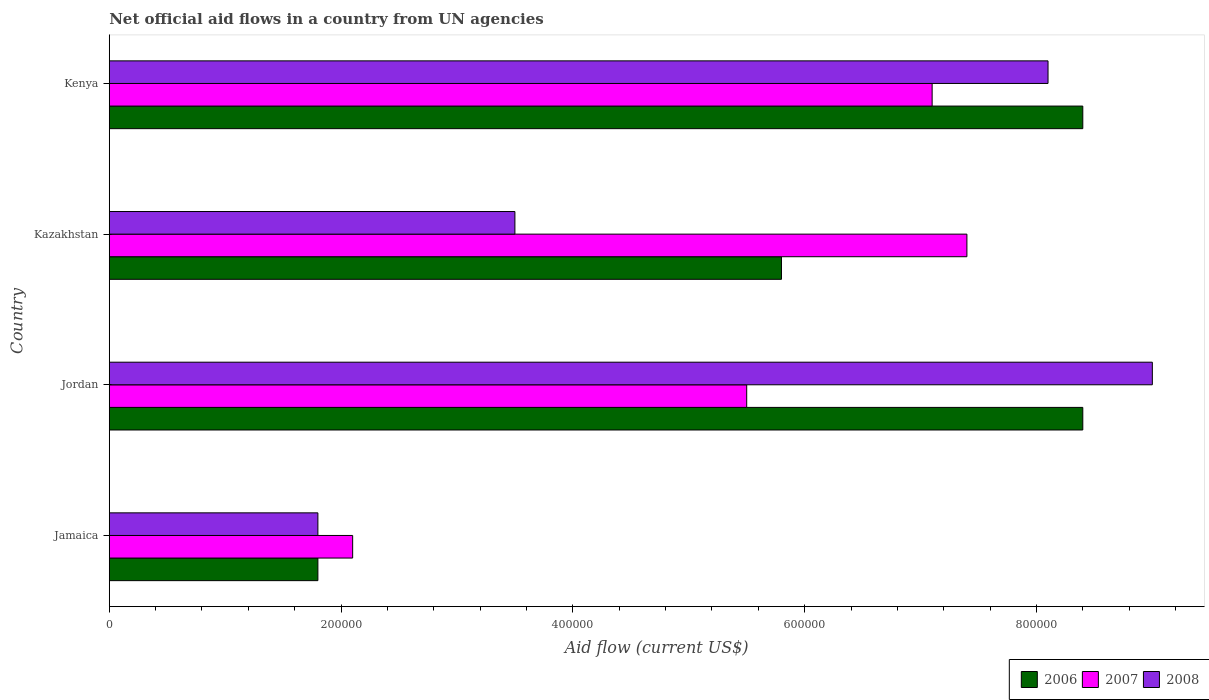How many groups of bars are there?
Your answer should be compact. 4. Are the number of bars on each tick of the Y-axis equal?
Make the answer very short. Yes. How many bars are there on the 2nd tick from the top?
Ensure brevity in your answer.  3. What is the label of the 3rd group of bars from the top?
Your answer should be compact. Jordan. Across all countries, what is the maximum net official aid flow in 2007?
Keep it short and to the point. 7.40e+05. In which country was the net official aid flow in 2006 maximum?
Your answer should be very brief. Jordan. In which country was the net official aid flow in 2006 minimum?
Keep it short and to the point. Jamaica. What is the total net official aid flow in 2006 in the graph?
Give a very brief answer. 2.44e+06. What is the difference between the net official aid flow in 2008 in Kazakhstan and that in Kenya?
Your answer should be very brief. -4.60e+05. What is the average net official aid flow in 2007 per country?
Your answer should be compact. 5.52e+05. What is the ratio of the net official aid flow in 2006 in Jamaica to that in Jordan?
Offer a very short reply. 0.21. Is the net official aid flow in 2006 in Jordan less than that in Kazakhstan?
Keep it short and to the point. No. What is the difference between the highest and the lowest net official aid flow in 2007?
Make the answer very short. 5.30e+05. In how many countries, is the net official aid flow in 2007 greater than the average net official aid flow in 2007 taken over all countries?
Your answer should be very brief. 2. Is the sum of the net official aid flow in 2008 in Kazakhstan and Kenya greater than the maximum net official aid flow in 2007 across all countries?
Provide a short and direct response. Yes. What does the 1st bar from the top in Kenya represents?
Your answer should be compact. 2008. Is it the case that in every country, the sum of the net official aid flow in 2007 and net official aid flow in 2008 is greater than the net official aid flow in 2006?
Give a very brief answer. Yes. How many bars are there?
Offer a very short reply. 12. How many countries are there in the graph?
Provide a succinct answer. 4. What is the difference between two consecutive major ticks on the X-axis?
Provide a succinct answer. 2.00e+05. Are the values on the major ticks of X-axis written in scientific E-notation?
Ensure brevity in your answer.  No. Does the graph contain any zero values?
Offer a terse response. No. What is the title of the graph?
Offer a very short reply. Net official aid flows in a country from UN agencies. What is the label or title of the X-axis?
Keep it short and to the point. Aid flow (current US$). What is the label or title of the Y-axis?
Your answer should be very brief. Country. What is the Aid flow (current US$) in 2006 in Jamaica?
Provide a succinct answer. 1.80e+05. What is the Aid flow (current US$) in 2008 in Jamaica?
Make the answer very short. 1.80e+05. What is the Aid flow (current US$) of 2006 in Jordan?
Ensure brevity in your answer.  8.40e+05. What is the Aid flow (current US$) of 2008 in Jordan?
Make the answer very short. 9.00e+05. What is the Aid flow (current US$) in 2006 in Kazakhstan?
Give a very brief answer. 5.80e+05. What is the Aid flow (current US$) of 2007 in Kazakhstan?
Ensure brevity in your answer.  7.40e+05. What is the Aid flow (current US$) of 2006 in Kenya?
Keep it short and to the point. 8.40e+05. What is the Aid flow (current US$) of 2007 in Kenya?
Offer a terse response. 7.10e+05. What is the Aid flow (current US$) in 2008 in Kenya?
Ensure brevity in your answer.  8.10e+05. Across all countries, what is the maximum Aid flow (current US$) of 2006?
Give a very brief answer. 8.40e+05. Across all countries, what is the maximum Aid flow (current US$) in 2007?
Your response must be concise. 7.40e+05. Across all countries, what is the minimum Aid flow (current US$) of 2007?
Provide a succinct answer. 2.10e+05. Across all countries, what is the minimum Aid flow (current US$) in 2008?
Ensure brevity in your answer.  1.80e+05. What is the total Aid flow (current US$) in 2006 in the graph?
Provide a succinct answer. 2.44e+06. What is the total Aid flow (current US$) of 2007 in the graph?
Your answer should be compact. 2.21e+06. What is the total Aid flow (current US$) in 2008 in the graph?
Make the answer very short. 2.24e+06. What is the difference between the Aid flow (current US$) of 2006 in Jamaica and that in Jordan?
Give a very brief answer. -6.60e+05. What is the difference between the Aid flow (current US$) of 2008 in Jamaica and that in Jordan?
Provide a succinct answer. -7.20e+05. What is the difference between the Aid flow (current US$) of 2006 in Jamaica and that in Kazakhstan?
Keep it short and to the point. -4.00e+05. What is the difference between the Aid flow (current US$) in 2007 in Jamaica and that in Kazakhstan?
Offer a very short reply. -5.30e+05. What is the difference between the Aid flow (current US$) of 2008 in Jamaica and that in Kazakhstan?
Keep it short and to the point. -1.70e+05. What is the difference between the Aid flow (current US$) of 2006 in Jamaica and that in Kenya?
Your answer should be compact. -6.60e+05. What is the difference between the Aid flow (current US$) of 2007 in Jamaica and that in Kenya?
Give a very brief answer. -5.00e+05. What is the difference between the Aid flow (current US$) in 2008 in Jamaica and that in Kenya?
Offer a terse response. -6.30e+05. What is the difference between the Aid flow (current US$) in 2006 in Jordan and that in Kazakhstan?
Keep it short and to the point. 2.60e+05. What is the difference between the Aid flow (current US$) in 2007 in Jordan and that in Kazakhstan?
Keep it short and to the point. -1.90e+05. What is the difference between the Aid flow (current US$) in 2006 in Jordan and that in Kenya?
Offer a terse response. 0. What is the difference between the Aid flow (current US$) in 2007 in Jordan and that in Kenya?
Offer a very short reply. -1.60e+05. What is the difference between the Aid flow (current US$) in 2008 in Jordan and that in Kenya?
Offer a very short reply. 9.00e+04. What is the difference between the Aid flow (current US$) of 2006 in Kazakhstan and that in Kenya?
Offer a very short reply. -2.60e+05. What is the difference between the Aid flow (current US$) in 2008 in Kazakhstan and that in Kenya?
Offer a very short reply. -4.60e+05. What is the difference between the Aid flow (current US$) of 2006 in Jamaica and the Aid flow (current US$) of 2007 in Jordan?
Offer a terse response. -3.70e+05. What is the difference between the Aid flow (current US$) in 2006 in Jamaica and the Aid flow (current US$) in 2008 in Jordan?
Your response must be concise. -7.20e+05. What is the difference between the Aid flow (current US$) in 2007 in Jamaica and the Aid flow (current US$) in 2008 in Jordan?
Offer a very short reply. -6.90e+05. What is the difference between the Aid flow (current US$) of 2006 in Jamaica and the Aid flow (current US$) of 2007 in Kazakhstan?
Your answer should be compact. -5.60e+05. What is the difference between the Aid flow (current US$) of 2006 in Jamaica and the Aid flow (current US$) of 2008 in Kazakhstan?
Provide a short and direct response. -1.70e+05. What is the difference between the Aid flow (current US$) of 2006 in Jamaica and the Aid flow (current US$) of 2007 in Kenya?
Your answer should be compact. -5.30e+05. What is the difference between the Aid flow (current US$) in 2006 in Jamaica and the Aid flow (current US$) in 2008 in Kenya?
Make the answer very short. -6.30e+05. What is the difference between the Aid flow (current US$) of 2007 in Jamaica and the Aid flow (current US$) of 2008 in Kenya?
Provide a short and direct response. -6.00e+05. What is the difference between the Aid flow (current US$) in 2006 in Jordan and the Aid flow (current US$) in 2008 in Kazakhstan?
Give a very brief answer. 4.90e+05. What is the difference between the Aid flow (current US$) in 2007 in Jordan and the Aid flow (current US$) in 2008 in Kazakhstan?
Provide a short and direct response. 2.00e+05. What is the difference between the Aid flow (current US$) of 2006 in Jordan and the Aid flow (current US$) of 2008 in Kenya?
Make the answer very short. 3.00e+04. What is the difference between the Aid flow (current US$) in 2007 in Jordan and the Aid flow (current US$) in 2008 in Kenya?
Your response must be concise. -2.60e+05. What is the difference between the Aid flow (current US$) in 2006 in Kazakhstan and the Aid flow (current US$) in 2007 in Kenya?
Your answer should be compact. -1.30e+05. What is the difference between the Aid flow (current US$) in 2006 in Kazakhstan and the Aid flow (current US$) in 2008 in Kenya?
Provide a short and direct response. -2.30e+05. What is the difference between the Aid flow (current US$) in 2007 in Kazakhstan and the Aid flow (current US$) in 2008 in Kenya?
Provide a succinct answer. -7.00e+04. What is the average Aid flow (current US$) of 2007 per country?
Keep it short and to the point. 5.52e+05. What is the average Aid flow (current US$) of 2008 per country?
Your answer should be compact. 5.60e+05. What is the difference between the Aid flow (current US$) in 2006 and Aid flow (current US$) in 2007 in Jamaica?
Provide a short and direct response. -3.00e+04. What is the difference between the Aid flow (current US$) in 2006 and Aid flow (current US$) in 2008 in Jamaica?
Offer a terse response. 0. What is the difference between the Aid flow (current US$) of 2006 and Aid flow (current US$) of 2007 in Jordan?
Give a very brief answer. 2.90e+05. What is the difference between the Aid flow (current US$) in 2006 and Aid flow (current US$) in 2008 in Jordan?
Your answer should be compact. -6.00e+04. What is the difference between the Aid flow (current US$) of 2007 and Aid flow (current US$) of 2008 in Jordan?
Offer a very short reply. -3.50e+05. What is the difference between the Aid flow (current US$) in 2006 and Aid flow (current US$) in 2007 in Kazakhstan?
Give a very brief answer. -1.60e+05. What is the difference between the Aid flow (current US$) of 2006 and Aid flow (current US$) of 2008 in Kenya?
Provide a succinct answer. 3.00e+04. What is the difference between the Aid flow (current US$) of 2007 and Aid flow (current US$) of 2008 in Kenya?
Keep it short and to the point. -1.00e+05. What is the ratio of the Aid flow (current US$) in 2006 in Jamaica to that in Jordan?
Your answer should be compact. 0.21. What is the ratio of the Aid flow (current US$) of 2007 in Jamaica to that in Jordan?
Your response must be concise. 0.38. What is the ratio of the Aid flow (current US$) of 2008 in Jamaica to that in Jordan?
Your answer should be very brief. 0.2. What is the ratio of the Aid flow (current US$) of 2006 in Jamaica to that in Kazakhstan?
Your answer should be compact. 0.31. What is the ratio of the Aid flow (current US$) in 2007 in Jamaica to that in Kazakhstan?
Give a very brief answer. 0.28. What is the ratio of the Aid flow (current US$) in 2008 in Jamaica to that in Kazakhstan?
Give a very brief answer. 0.51. What is the ratio of the Aid flow (current US$) of 2006 in Jamaica to that in Kenya?
Offer a terse response. 0.21. What is the ratio of the Aid flow (current US$) of 2007 in Jamaica to that in Kenya?
Keep it short and to the point. 0.3. What is the ratio of the Aid flow (current US$) in 2008 in Jamaica to that in Kenya?
Your answer should be compact. 0.22. What is the ratio of the Aid flow (current US$) in 2006 in Jordan to that in Kazakhstan?
Offer a terse response. 1.45. What is the ratio of the Aid flow (current US$) of 2007 in Jordan to that in Kazakhstan?
Offer a terse response. 0.74. What is the ratio of the Aid flow (current US$) of 2008 in Jordan to that in Kazakhstan?
Make the answer very short. 2.57. What is the ratio of the Aid flow (current US$) of 2007 in Jordan to that in Kenya?
Make the answer very short. 0.77. What is the ratio of the Aid flow (current US$) in 2008 in Jordan to that in Kenya?
Provide a short and direct response. 1.11. What is the ratio of the Aid flow (current US$) of 2006 in Kazakhstan to that in Kenya?
Ensure brevity in your answer.  0.69. What is the ratio of the Aid flow (current US$) of 2007 in Kazakhstan to that in Kenya?
Make the answer very short. 1.04. What is the ratio of the Aid flow (current US$) of 2008 in Kazakhstan to that in Kenya?
Offer a terse response. 0.43. What is the difference between the highest and the second highest Aid flow (current US$) of 2008?
Provide a short and direct response. 9.00e+04. What is the difference between the highest and the lowest Aid flow (current US$) of 2006?
Your answer should be very brief. 6.60e+05. What is the difference between the highest and the lowest Aid flow (current US$) of 2007?
Keep it short and to the point. 5.30e+05. What is the difference between the highest and the lowest Aid flow (current US$) in 2008?
Your answer should be compact. 7.20e+05. 